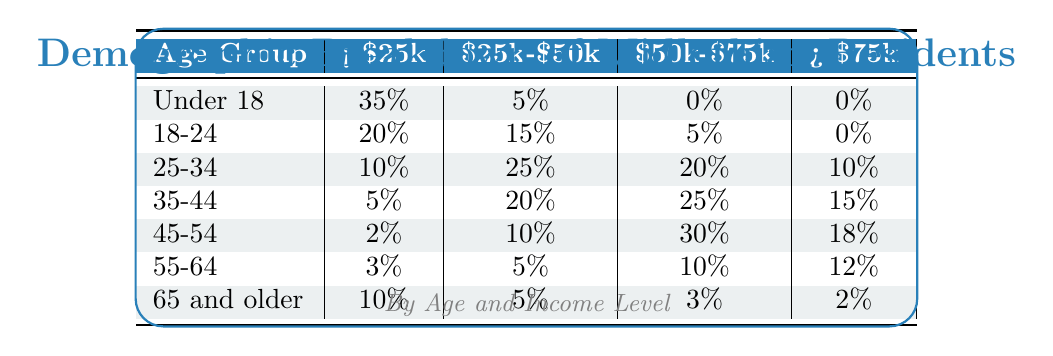What percentage of residents aged 25-34 earn less than $25k? According to the table, the percentage of residents in the 25-34 age group earning less than $25k is listed directly under the '< $25k' column, which shows 10%.
Answer: 10% Which age group has the highest percentage of individuals earning between $50k and $75k? Looking at the '< $50k' column, the age group 45-54 has the highest percentage of 30%, which exceeds all the other age groups in this income range.
Answer: 45-54 Is it true that no individuals aged 18-24 earn more than $75k? Checking the row for the 18-24 age group, the table shows that the percentage in the '> $75k' column is 0%, confirming that no individuals in this age group earn more than $75k.
Answer: Yes What is the total percentage of residents aged 35-44 earning less than $50k? For the age group 35-44, the sum of percentages in the '< $25k' and '$25k-$50k' columns is calculated as 5% + 20% = 25%. Thus, the total percentage earning less than $50k is 25%.
Answer: 25% Which income category has the highest total percentage across all age groups? To find this, we sum each column's percentage: for '< $25k', the total is 85%; for '$25k-$50k', the total is 55%; for '$50k-$75k', the total is 68%; and for '> $75k', the total is 57%. The highest total is for the '< $25k' income category at 85%.
Answer: < $25k How many age groups have more than 20% of their residents earning between $25k and $50k? By examining the '$25k-$50k' column, the age groups 18-24 (15%), 25-34 (25%), 35-44 (20%), 45-54 (10%), 55-64 (5%), and 65 and older (5%) have 25% or more only in the 25-34 age group. Thus, only one age group qualifies.
Answer: 1 What is the difference in the percentage of individuals earning more than $75k between the age groups 45-54 and 25-34? The percentage for 45-54 is 18% and for 25-34 is 10%. The difference is calculated as 18% - 10% = 8%.
Answer: 8% For residents aged 55-64, what is the percentage of those earning less than $25k compared to those earning between $50k and $75k? For the age group 55-64, less than $25k is 3% and between $50k and $75k is 10%. The percentage earning less than $25k is lower than those earning between $50k and $75k.
Answer: Lower How many total residents across all age groups earn between $50k and $75k? The percentages for each age group in the '$50k-$75k' column are 0% + 5% + 20% + 25% + 30% + 10% + 3% = 93%. This total shows the combined percentage of residents earning within this income bracket across all age groups.
Answer: 93% 